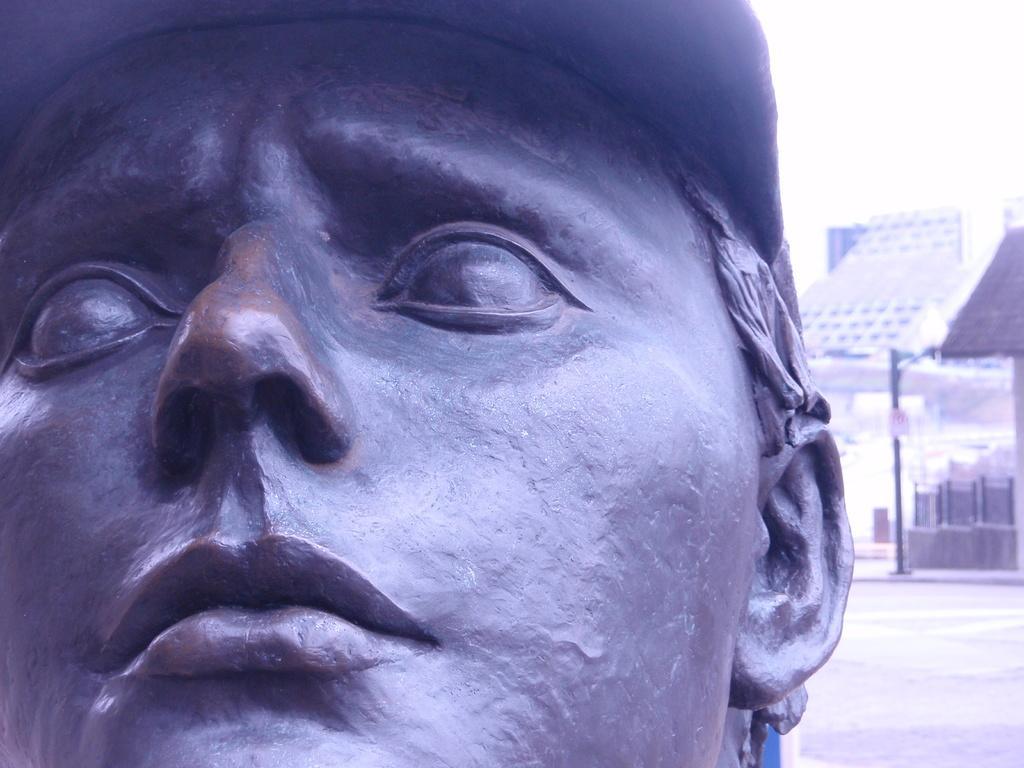In one or two sentences, can you explain what this image depicts? This is a statue of a person's face, which is black in color. In the background, I think these are the buildings. This looks like a pole. 